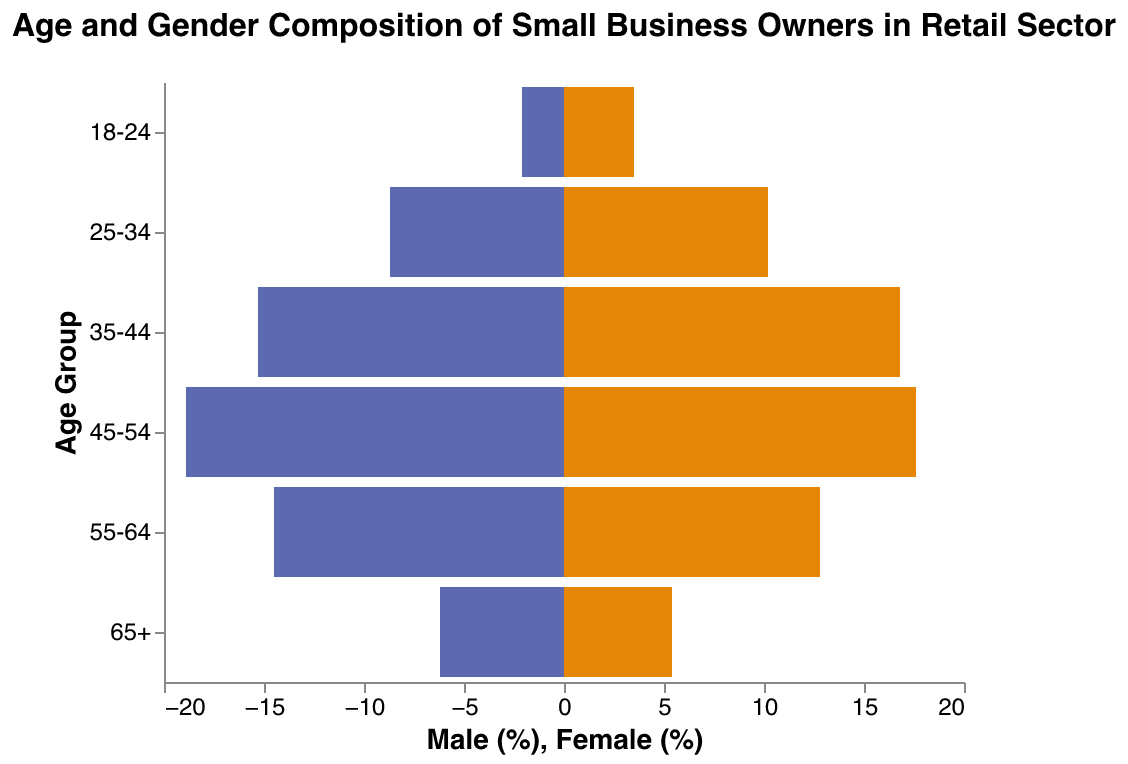What is the age group with the highest percentage of male small business owners? Look at the male bar's highest point and identify the respective age group on the y-axis. The age group is 45-54.
Answer: 45-54 Which gender has more small business owners in the 35-44 age group? Compare the lengths of the bars for males and females in the 35-44 age group. The female bar is longer than the male bar.
Answer: Female How many age groups have a higher percentage of female small business owners compared to males? Compare each pair of bars and count the age groups where the female bar is longer than the male bar. These age groups are 18-24, 25-34, and 35-44.
Answer: 3 What is the total percentage of small business owners (male and female combined) in the 55-64 age group? Add the percentages of males and females in the 55-64 age group. The sum is 14.5% + 12.8%.
Answer: 27.3% Is the percentage of male small business owners higher in the 65+ age group compared to the 18-24 age group? Compare the lengths of the bars for males in the 65+ and 18-24 age groups. The length of the bar for males in the 65+ age group (6.2%) is higher than that in the 18-24 age group (2.1%).
Answer: Yes Which age group has the smallest gender gap in small business ownership? Calculate the absolute difference between the male and female bars for each age group and identify the smallest difference. The age group 45-54 has the least difference:
Answer: 45-54 Between the 25-34 and 55-64 age groups, in which age group is the percentage of female small business owners higher? Compare the lengths of the female bars in the 25-34 and 55-64 age groups. The length of the female bar in the 25-34 age group (10.2%) is higher than that in the 55-64 age group (12.8%).
Answer: 25-34 Is the number of male small business owners aged 35-44 more than twice that of the 18-24 age group? Compare the percentage of males in the 35-44 age group (15.3%) to twice the percentage in the 18-24 age group (2.1% * 2 = 4.2%). 15.3% is more than 4.2%.
Answer: Yes What percentage of the 45-54 age group are female small business owners? Locate the female bar in the 45-54 age group and read the value next to it, which is 17.6%.
Answer: 17.6% How does the gender balance change from the 18-24 age group to the 35-44 age group? Examine the lengths of the bars for males and females in the 18-24, 25-34, and 35-44 age groups and observe the changes. In the 18-24 age group, females lead by 1.4%, but males gradually catch up so that by the 35-44 age group, females lead by only 1.5%.
Answer: Gender gap decreases in favor of males 